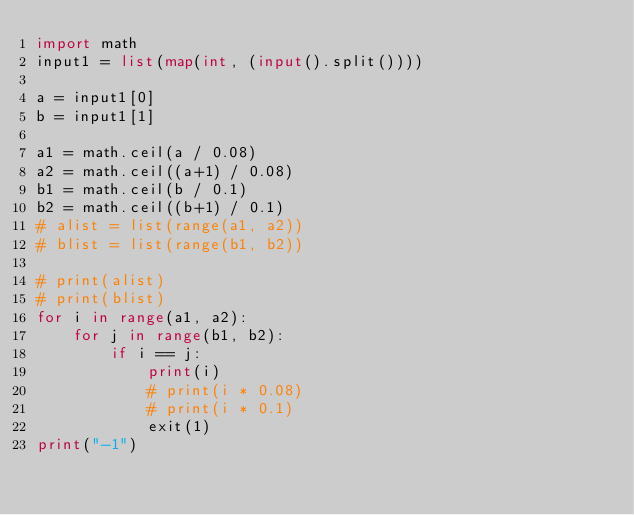Convert code to text. <code><loc_0><loc_0><loc_500><loc_500><_Python_>import math
input1 = list(map(int, (input().split())))

a = input1[0]
b = input1[1]

a1 = math.ceil(a / 0.08)
a2 = math.ceil((a+1) / 0.08)
b1 = math.ceil(b / 0.1)
b2 = math.ceil((b+1) / 0.1)
# alist = list(range(a1, a2))
# blist = list(range(b1, b2))

# print(alist)
# print(blist)
for i in range(a1, a2):
    for j in range(b1, b2):
        if i == j:
            print(i)
            # print(i * 0.08)
            # print(i * 0.1)
            exit(1)
print("-1")
</code> 